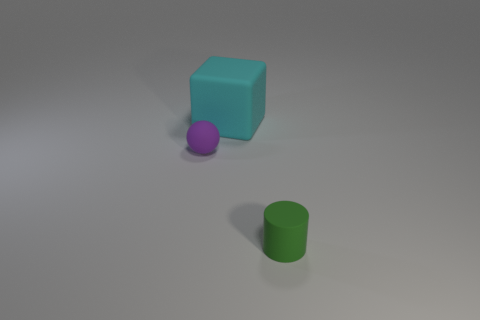Add 3 large yellow metal spheres. How many objects exist? 6 Subtract all balls. How many objects are left? 2 Add 1 cyan blocks. How many cyan blocks exist? 2 Subtract 0 red balls. How many objects are left? 3 Subtract all cyan rubber blocks. Subtract all tiny purple shiny things. How many objects are left? 2 Add 2 rubber things. How many rubber things are left? 5 